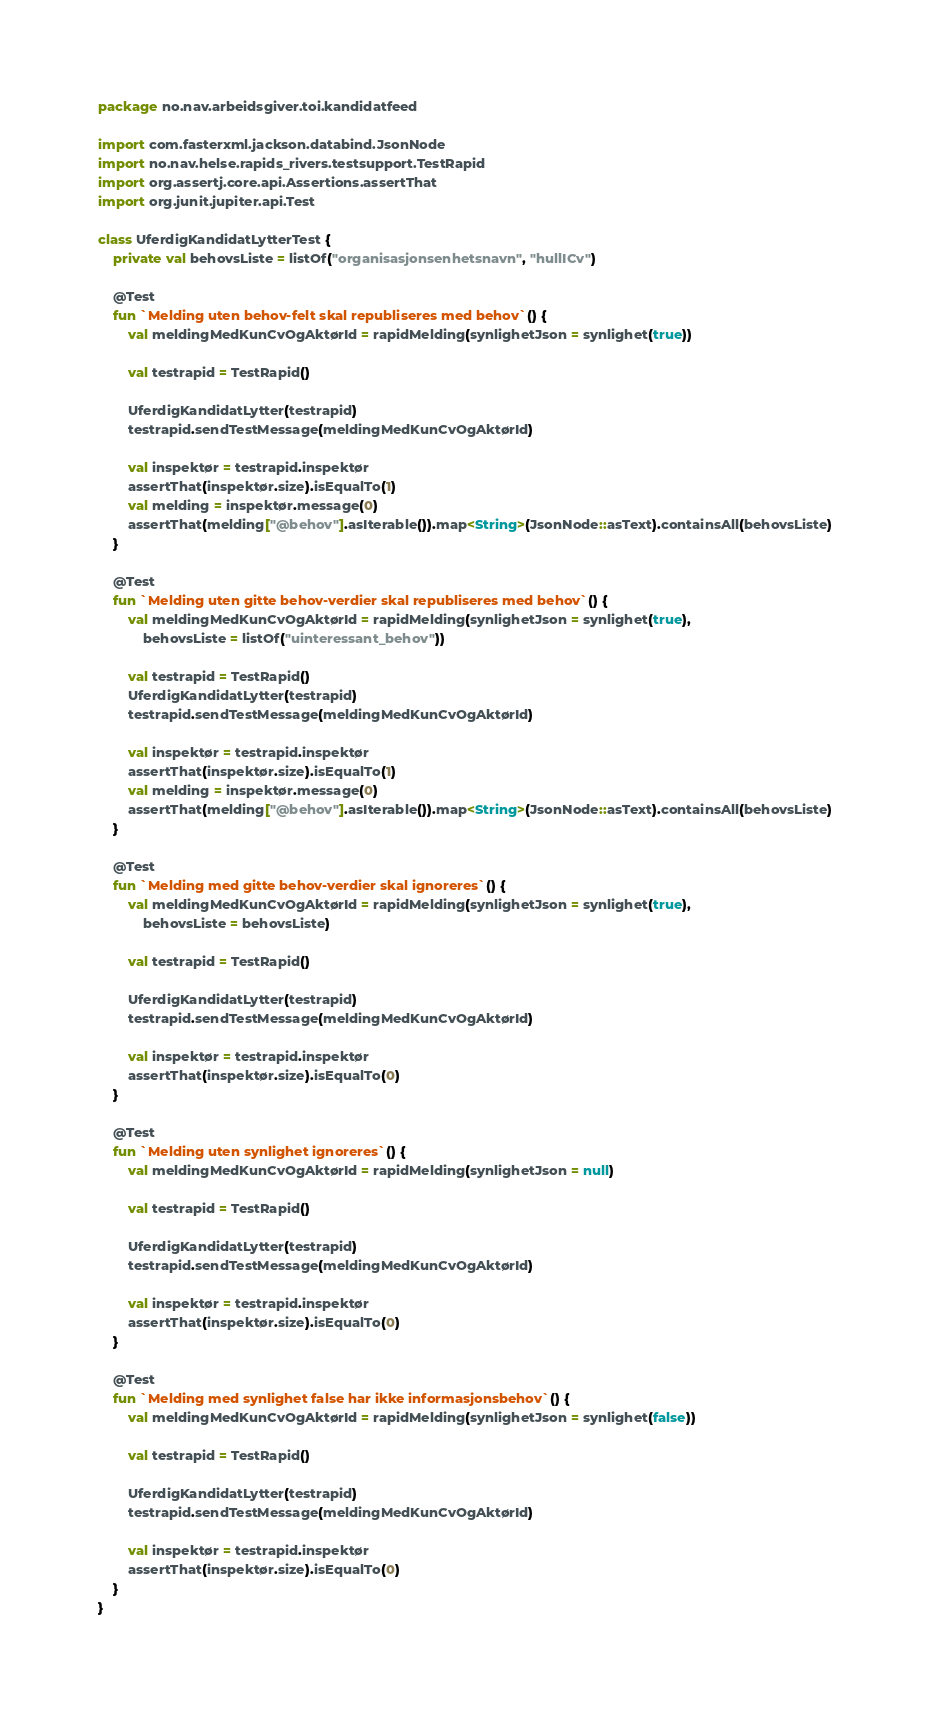<code> <loc_0><loc_0><loc_500><loc_500><_Kotlin_>package no.nav.arbeidsgiver.toi.kandidatfeed

import com.fasterxml.jackson.databind.JsonNode
import no.nav.helse.rapids_rivers.testsupport.TestRapid
import org.assertj.core.api.Assertions.assertThat
import org.junit.jupiter.api.Test

class UferdigKandidatLytterTest {
    private val behovsListe = listOf("organisasjonsenhetsnavn", "hullICv")

    @Test
    fun `Melding uten behov-felt skal republiseres med behov`() {
        val meldingMedKunCvOgAktørId = rapidMelding(synlighetJson = synlighet(true))

        val testrapid = TestRapid()

        UferdigKandidatLytter(testrapid)
        testrapid.sendTestMessage(meldingMedKunCvOgAktørId)

        val inspektør = testrapid.inspektør
        assertThat(inspektør.size).isEqualTo(1)
        val melding = inspektør.message(0)
        assertThat(melding["@behov"].asIterable()).map<String>(JsonNode::asText).containsAll(behovsListe)
    }

    @Test
    fun `Melding uten gitte behov-verdier skal republiseres med behov`() {
        val meldingMedKunCvOgAktørId = rapidMelding(synlighetJson = synlighet(true),
            behovsListe = listOf("uinteressant_behov"))

        val testrapid = TestRapid()
        UferdigKandidatLytter(testrapid)
        testrapid.sendTestMessage(meldingMedKunCvOgAktørId)

        val inspektør = testrapid.inspektør
        assertThat(inspektør.size).isEqualTo(1)
        val melding = inspektør.message(0)
        assertThat(melding["@behov"].asIterable()).map<String>(JsonNode::asText).containsAll(behovsListe)
    }

    @Test
    fun `Melding med gitte behov-verdier skal ignoreres`() {
        val meldingMedKunCvOgAktørId = rapidMelding(synlighetJson = synlighet(true),
            behovsListe = behovsListe)

        val testrapid = TestRapid()

        UferdigKandidatLytter(testrapid)
        testrapid.sendTestMessage(meldingMedKunCvOgAktørId)

        val inspektør = testrapid.inspektør
        assertThat(inspektør.size).isEqualTo(0)
    }

    @Test
    fun `Melding uten synlighet ignoreres`() {
        val meldingMedKunCvOgAktørId = rapidMelding(synlighetJson = null)

        val testrapid = TestRapid()

        UferdigKandidatLytter(testrapid)
        testrapid.sendTestMessage(meldingMedKunCvOgAktørId)

        val inspektør = testrapid.inspektør
        assertThat(inspektør.size).isEqualTo(0)
    }

    @Test
    fun `Melding med synlighet false har ikke informasjonsbehov`() {
        val meldingMedKunCvOgAktørId = rapidMelding(synlighetJson = synlighet(false))

        val testrapid = TestRapid()

        UferdigKandidatLytter(testrapid)
        testrapid.sendTestMessage(meldingMedKunCvOgAktørId)

        val inspektør = testrapid.inspektør
        assertThat(inspektør.size).isEqualTo(0)
    }
}</code> 